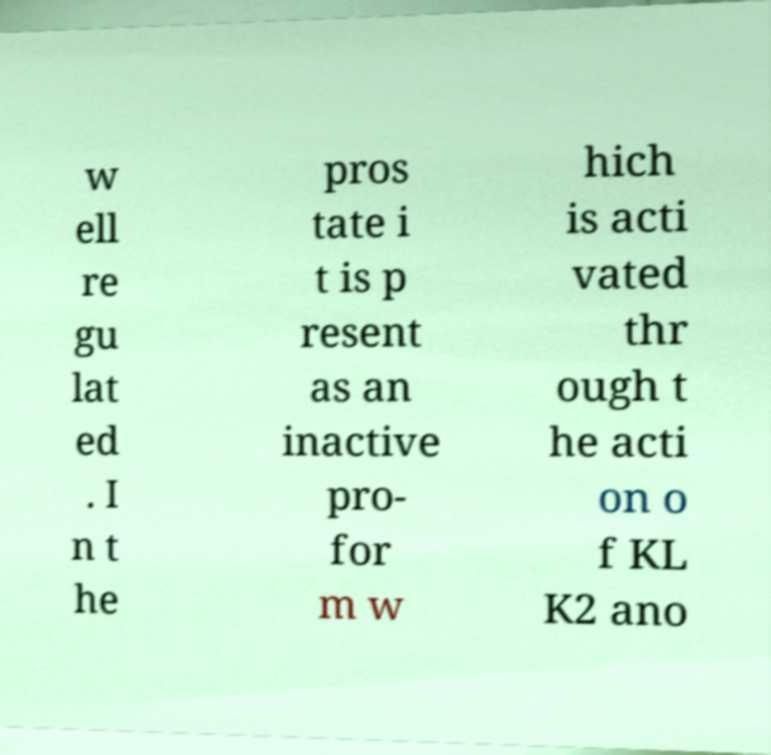I need the written content from this picture converted into text. Can you do that? w ell re gu lat ed . I n t he pros tate i t is p resent as an inactive pro- for m w hich is acti vated thr ough t he acti on o f KL K2 ano 